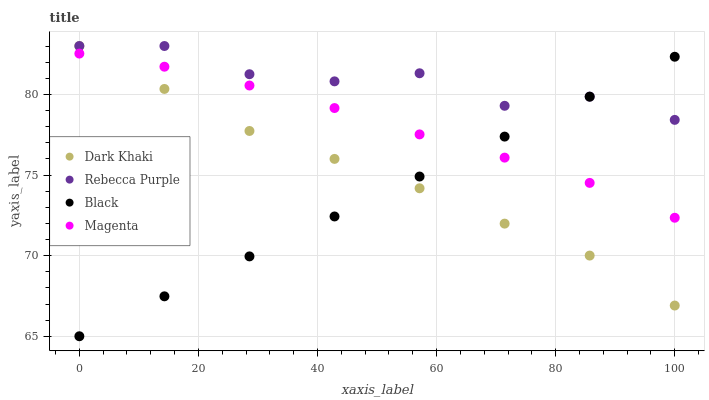Does Black have the minimum area under the curve?
Answer yes or no. Yes. Does Rebecca Purple have the maximum area under the curve?
Answer yes or no. Yes. Does Magenta have the minimum area under the curve?
Answer yes or no. No. Does Magenta have the maximum area under the curve?
Answer yes or no. No. Is Black the smoothest?
Answer yes or no. Yes. Is Rebecca Purple the roughest?
Answer yes or no. Yes. Is Magenta the smoothest?
Answer yes or no. No. Is Magenta the roughest?
Answer yes or no. No. Does Black have the lowest value?
Answer yes or no. Yes. Does Magenta have the lowest value?
Answer yes or no. No. Does Rebecca Purple have the highest value?
Answer yes or no. Yes. Does Magenta have the highest value?
Answer yes or no. No. Is Magenta less than Rebecca Purple?
Answer yes or no. Yes. Is Rebecca Purple greater than Magenta?
Answer yes or no. Yes. Does Black intersect Rebecca Purple?
Answer yes or no. Yes. Is Black less than Rebecca Purple?
Answer yes or no. No. Is Black greater than Rebecca Purple?
Answer yes or no. No. Does Magenta intersect Rebecca Purple?
Answer yes or no. No. 